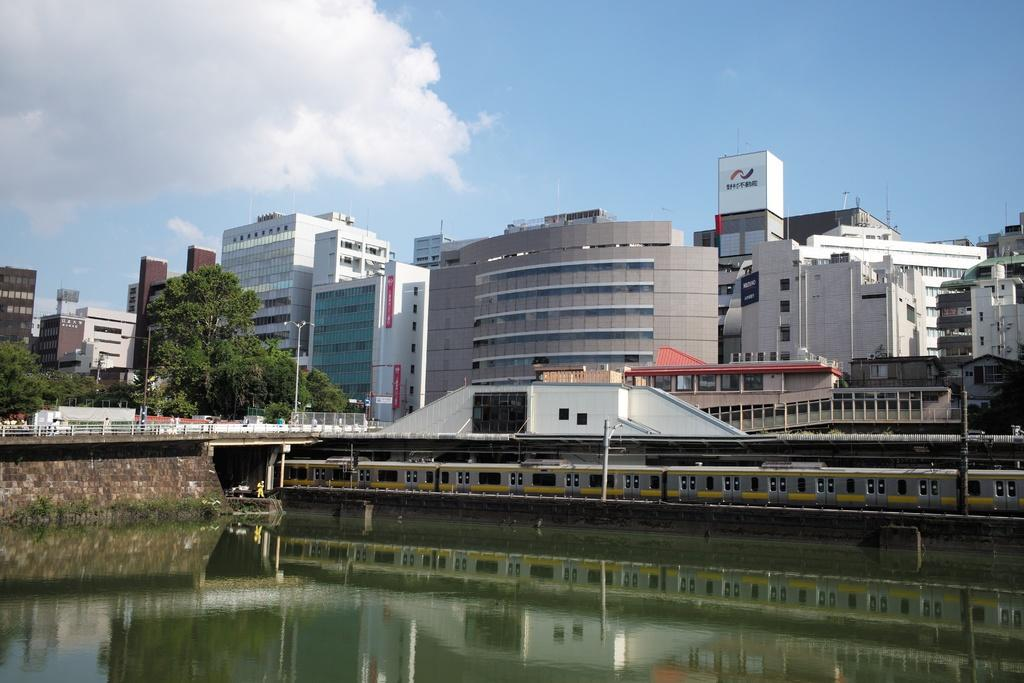What is the main subject of the image? The main subject of the image is a train moving on the railway track. What can be seen in the background of the image? In the background of the image, there are buildings, trees, and the sky. What is the condition of the sky in the image? The sky is visible in the background of the image, and clouds are present. What other structures are present in the image? There is a bridge, poles, and light poles in the image. How many types of structures can be seen in the image? There are at least three types of structures: a bridge, poles, and light poles. What type of test is being conducted on the truck in the image? There is no truck present in the image; it features a train moving on the railway track. Can you tell me how many fans are visible in the image? There are no fans present in the image. 